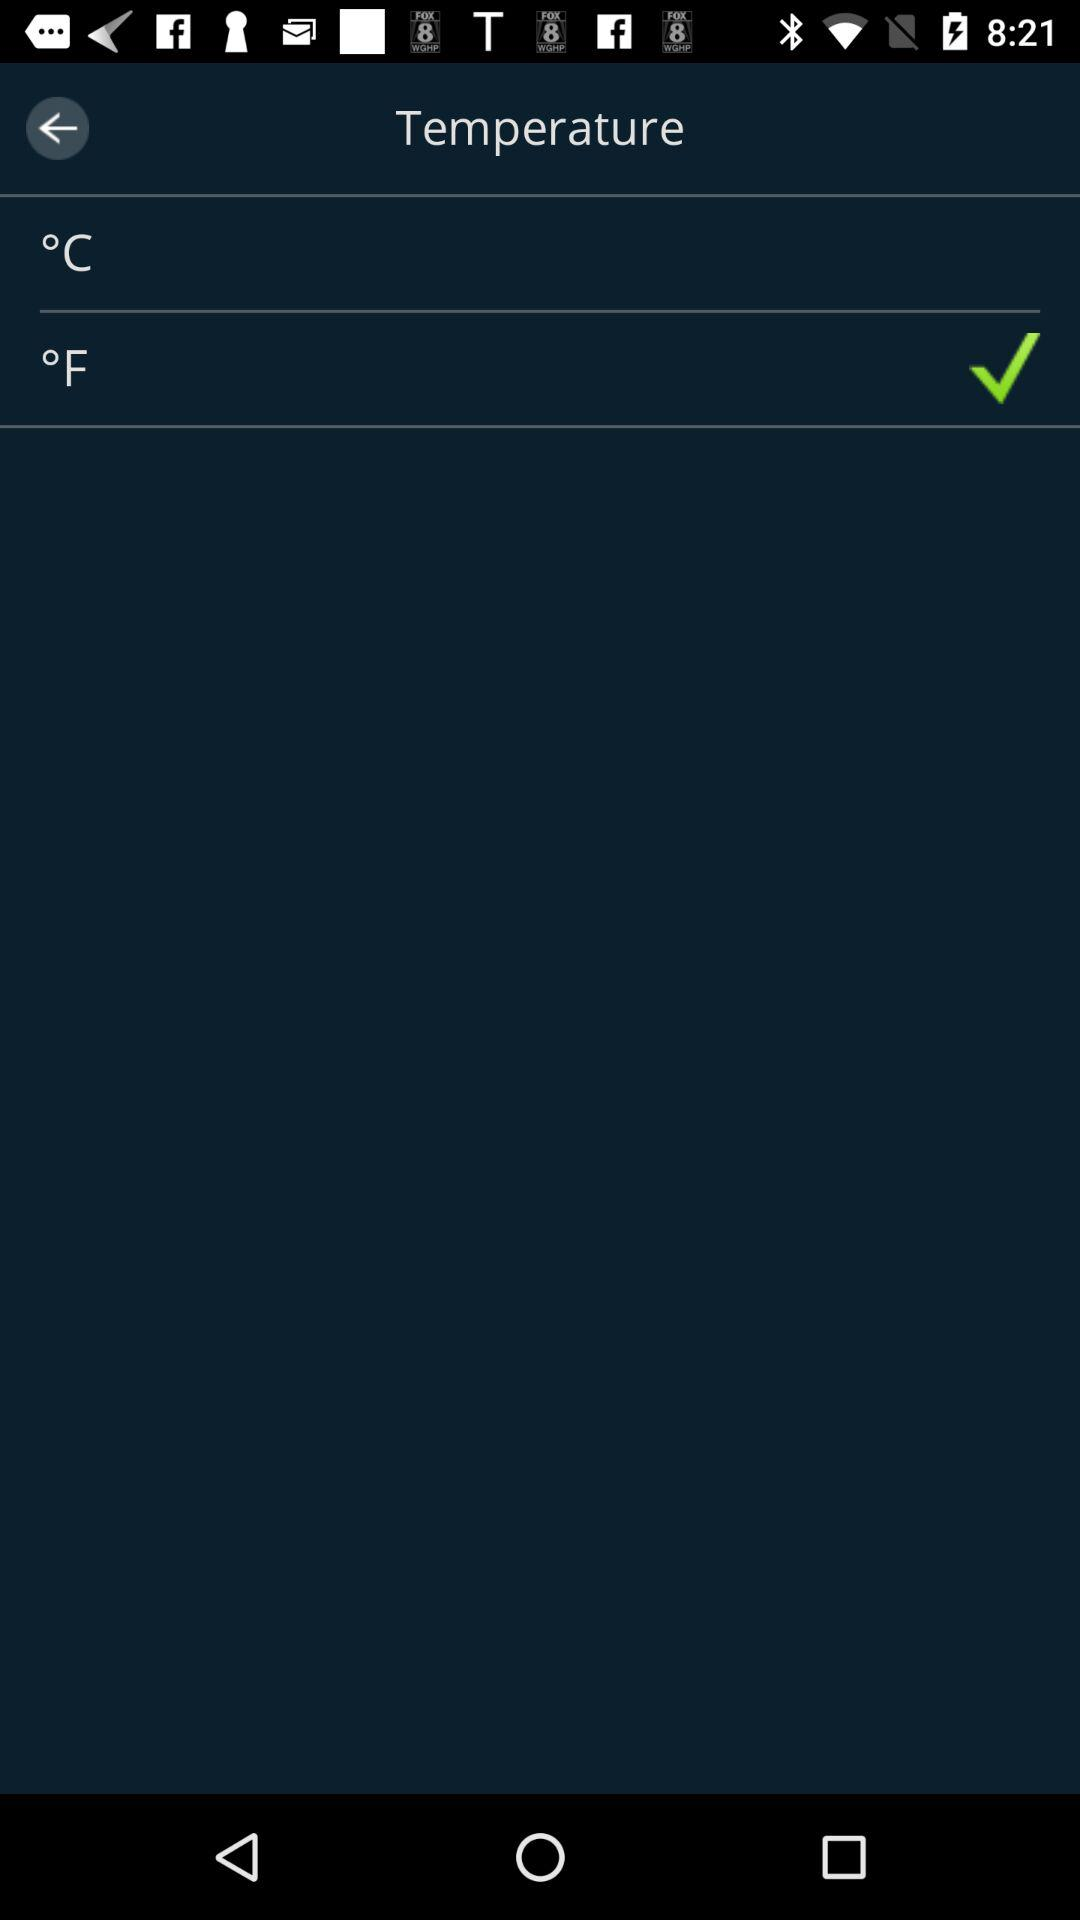Which option is checked? The checked option is "°F". 